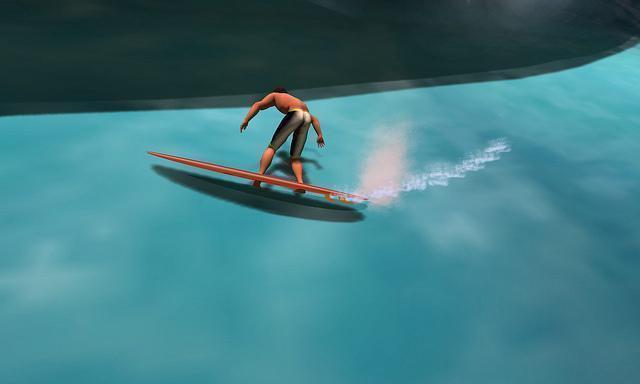How was this artwork created?
Make your selection from the four choices given to correctly answer the question.
Options: Photographed, digitally, painted, videoed. Digitally. 